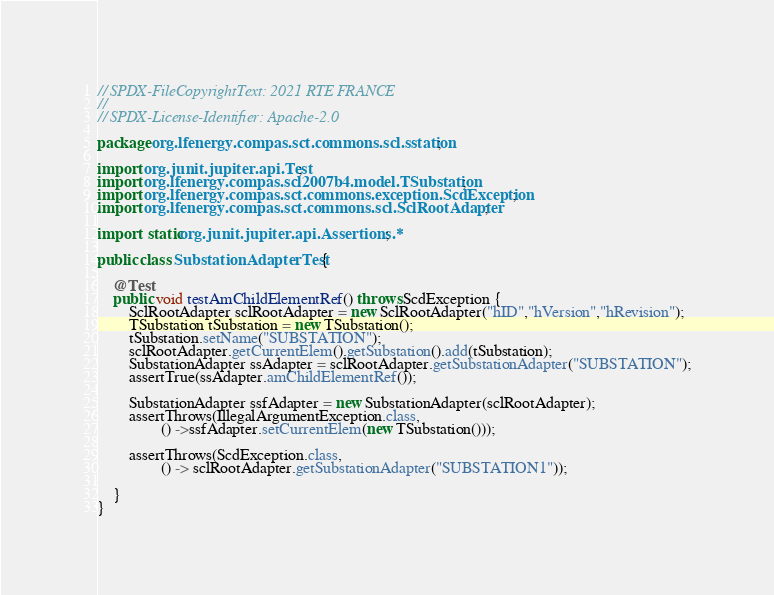<code> <loc_0><loc_0><loc_500><loc_500><_Java_>// SPDX-FileCopyrightText: 2021 RTE FRANCE
//
// SPDX-License-Identifier: Apache-2.0

package org.lfenergy.compas.sct.commons.scl.sstation;

import org.junit.jupiter.api.Test;
import org.lfenergy.compas.scl2007b4.model.TSubstation;
import org.lfenergy.compas.sct.commons.exception.ScdException;
import org.lfenergy.compas.sct.commons.scl.SclRootAdapter;

import static org.junit.jupiter.api.Assertions.*;

public class SubstationAdapterTest {

    @Test
    public void testAmChildElementRef() throws ScdException {
        SclRootAdapter sclRootAdapter = new SclRootAdapter("hID","hVersion","hRevision");
        TSubstation tSubstation = new TSubstation();
        tSubstation.setName("SUBSTATION");
        sclRootAdapter.getCurrentElem().getSubstation().add(tSubstation);
        SubstationAdapter ssAdapter = sclRootAdapter.getSubstationAdapter("SUBSTATION");
        assertTrue(ssAdapter.amChildElementRef());

        SubstationAdapter ssfAdapter = new SubstationAdapter(sclRootAdapter);
        assertThrows(IllegalArgumentException.class,
                () ->ssfAdapter.setCurrentElem(new TSubstation()));

        assertThrows(ScdException.class,
                () -> sclRootAdapter.getSubstationAdapter("SUBSTATION1"));

    }
}</code> 